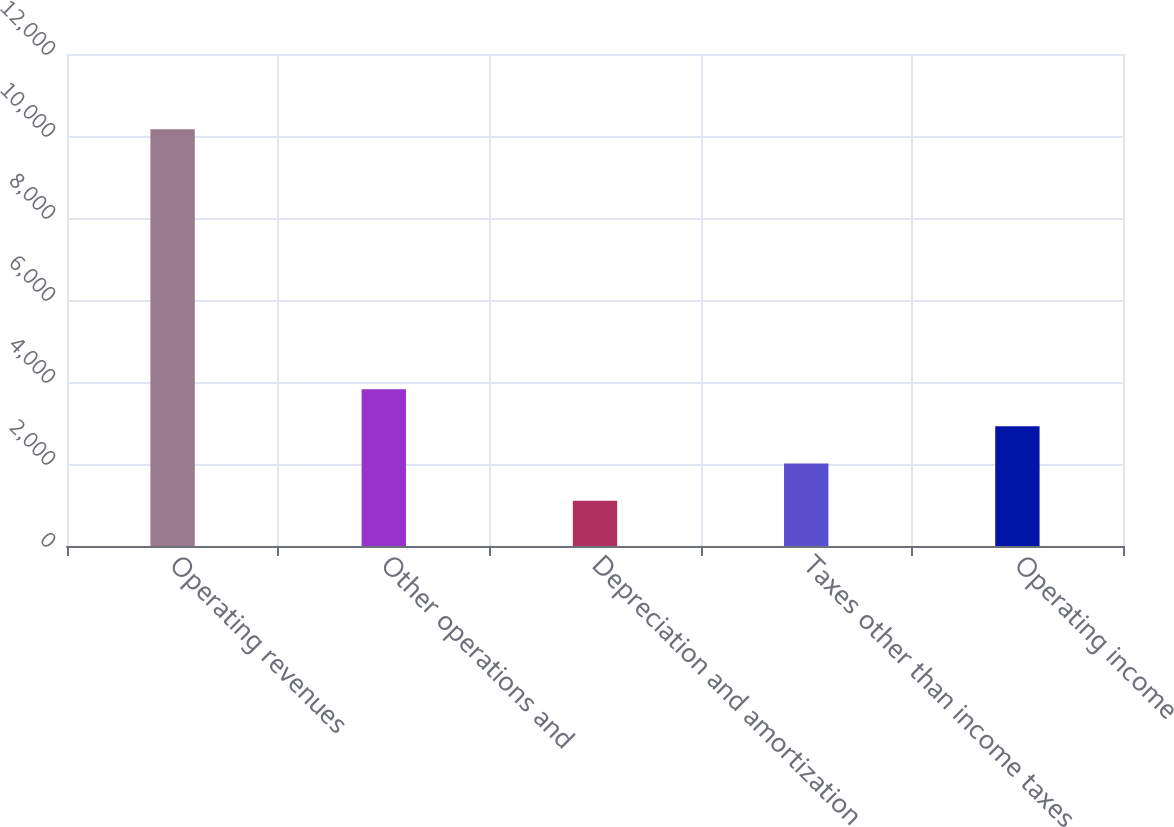<chart> <loc_0><loc_0><loc_500><loc_500><bar_chart><fcel>Operating revenues<fcel>Other operations and<fcel>Depreciation and amortization<fcel>Taxes other than income taxes<fcel>Operating income<nl><fcel>10165<fcel>3823.7<fcel>1106<fcel>2011.9<fcel>2917.8<nl></chart> 